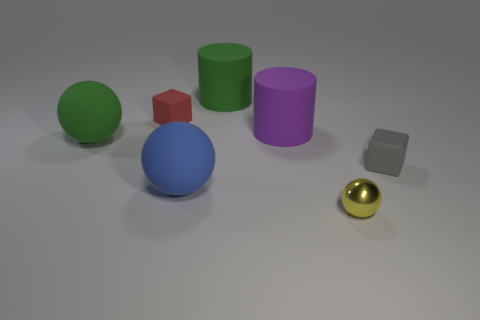Subtract all blue rubber balls. How many balls are left? 2 Add 2 large gray cubes. How many objects exist? 9 Subtract all blocks. How many objects are left? 5 Subtract all brown cubes. Subtract all yellow spheres. How many cubes are left? 2 Subtract all tiny red metal objects. Subtract all small red objects. How many objects are left? 6 Add 7 yellow shiny balls. How many yellow shiny balls are left? 8 Add 3 tiny purple shiny things. How many tiny purple shiny things exist? 3 Subtract 0 cyan cylinders. How many objects are left? 7 